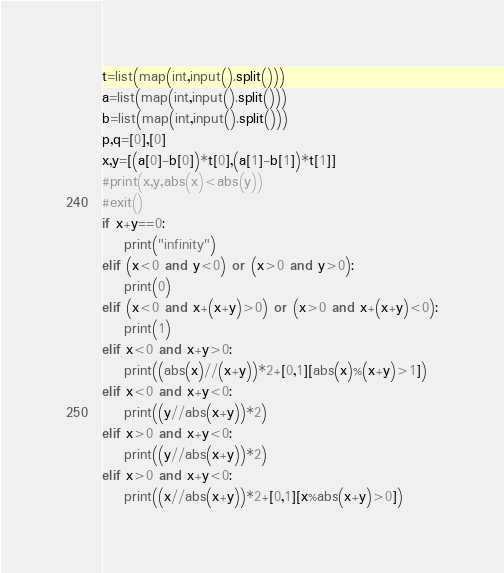<code> <loc_0><loc_0><loc_500><loc_500><_Python_>t=list(map(int,input().split()))
a=list(map(int,input().split()))
b=list(map(int,input().split()))
p,q=[0],[0]
x,y=[(a[0]-b[0])*t[0],(a[1]-b[1])*t[1]]
#print(x,y,abs(x)<abs(y))
#exit()
if x+y==0:
    print("infinity")
elif (x<0 and y<0) or (x>0 and y>0):
    print(0)
elif (x<0 and x+(x+y)>0) or (x>0 and x+(x+y)<0):
    print(1)
elif x<0 and x+y>0:
    print((abs(x)//(x+y))*2+[0,1][abs(x)%(x+y)>1])
elif x<0 and x+y<0:
    print((y//abs(x+y))*2)
elif x>0 and x+y<0:
    print((y//abs(x+y))*2)
elif x>0 and x+y<0:
    print((x//abs(x+y))*2+[0,1][x%abs(x+y)>0])</code> 